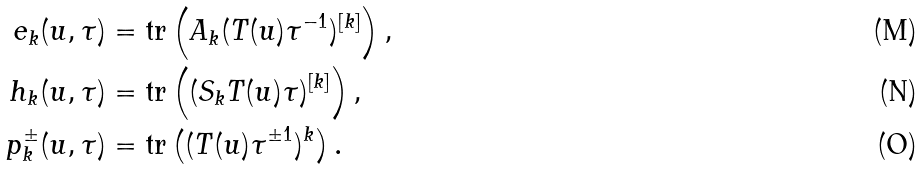Convert formula to latex. <formula><loc_0><loc_0><loc_500><loc_500>e _ { k } ( u , \tau ) & = \text {tr} \left ( A _ { k } ( T ( u ) \tau ^ { - 1 } ) ^ { [ k ] } \right ) , \\ { h } _ { k } ( u , \tau ) & = \text {tr} \left ( ( S _ { k } T ( u ) \tau ) ^ { [ k ] } \right ) , \\ { p } ^ { \pm } _ { k } ( u , \tau ) & = \text {tr} \left ( ( T ( u ) \tau ^ { \pm 1 } ) ^ { k } \right ) .</formula> 